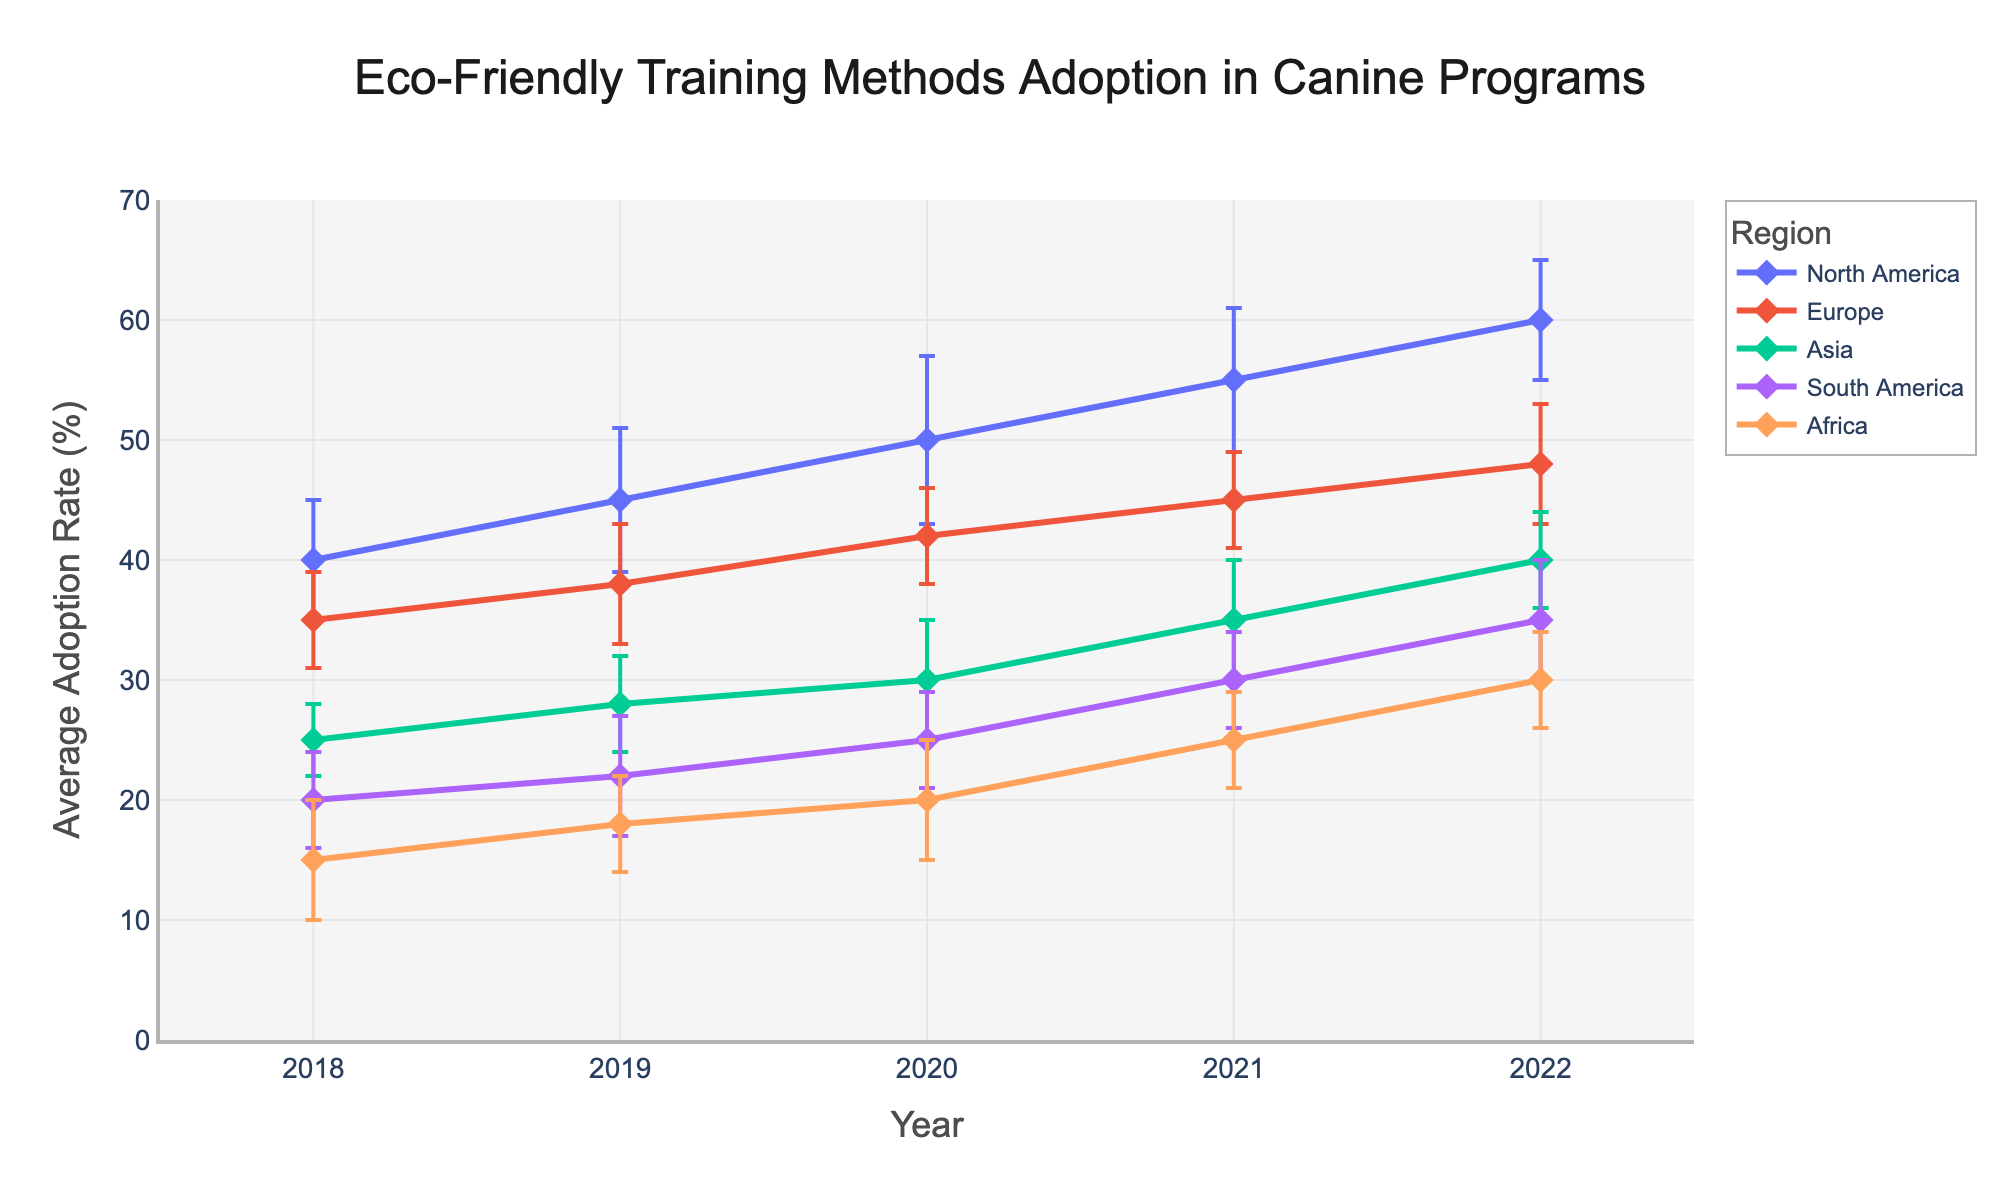What is the title of the figure? The title of the figure is located at the top of the chart. Read it directly from the figure.
Answer: Eco-Friendly Training Methods Adoption in Canine Programs Which region had the highest adoption rate of eco-friendly training methods in 2022? To find the region with the highest adoption rate in 2022, compare the values of all regions for that year. The figure shows that North America had the highest rate.
Answer: North America What was the average adoption rate of eco-friendly training methods in Asia for the year 2020? Look at the data point on the line for Asia in the year 2020. The figure shows an adoption rate.
Answer: 30% What is the difference in adoption rate between Europe and Africa in 2021? To find the difference, subtract the adoption rate of Africa from Europe in 2021. Europe had 45% and Africa had 25%, so the difference is 45% - 25%.
Answer: 20% Which regions show a consistent increase in adoption rates from 2018 to 2022? Inspect the figure and note the trends for each region over the years from 2018 to 2022. The regions with a steady incline, with no dips, are North America and Europe.
Answer: North America and Europe What is the standard deviation of the adoption rate for North America in 2020? Check the error bar for North America in 2020. The length of the error bar represents the standard deviation.
Answer: 7% How did the adoption rate in South America change from 2019 to 2022? To determine the change, look at the South America data points for 2019 and 2022 and note the adoption rates. It increased from 22% to 35%.
Answer: Increased by 13% Which year shows the highest average adoption rate of eco-friendly training methods across all regions? Calculate the average adoption rate for each year by adding up the adoption rates of all regions for that year and dividing by the number of regions (5), then compare these averages. The year with the highest average is 2022.
Answer: 2022 What was the rate of increase in the adoption rate of eco-friendly training methods in North America from 2018 to 2019? Subtract the 2018 adoption rate from the 2019 adoption rate for North America. The calculation is 45% - 40%.
Answer: 5% 